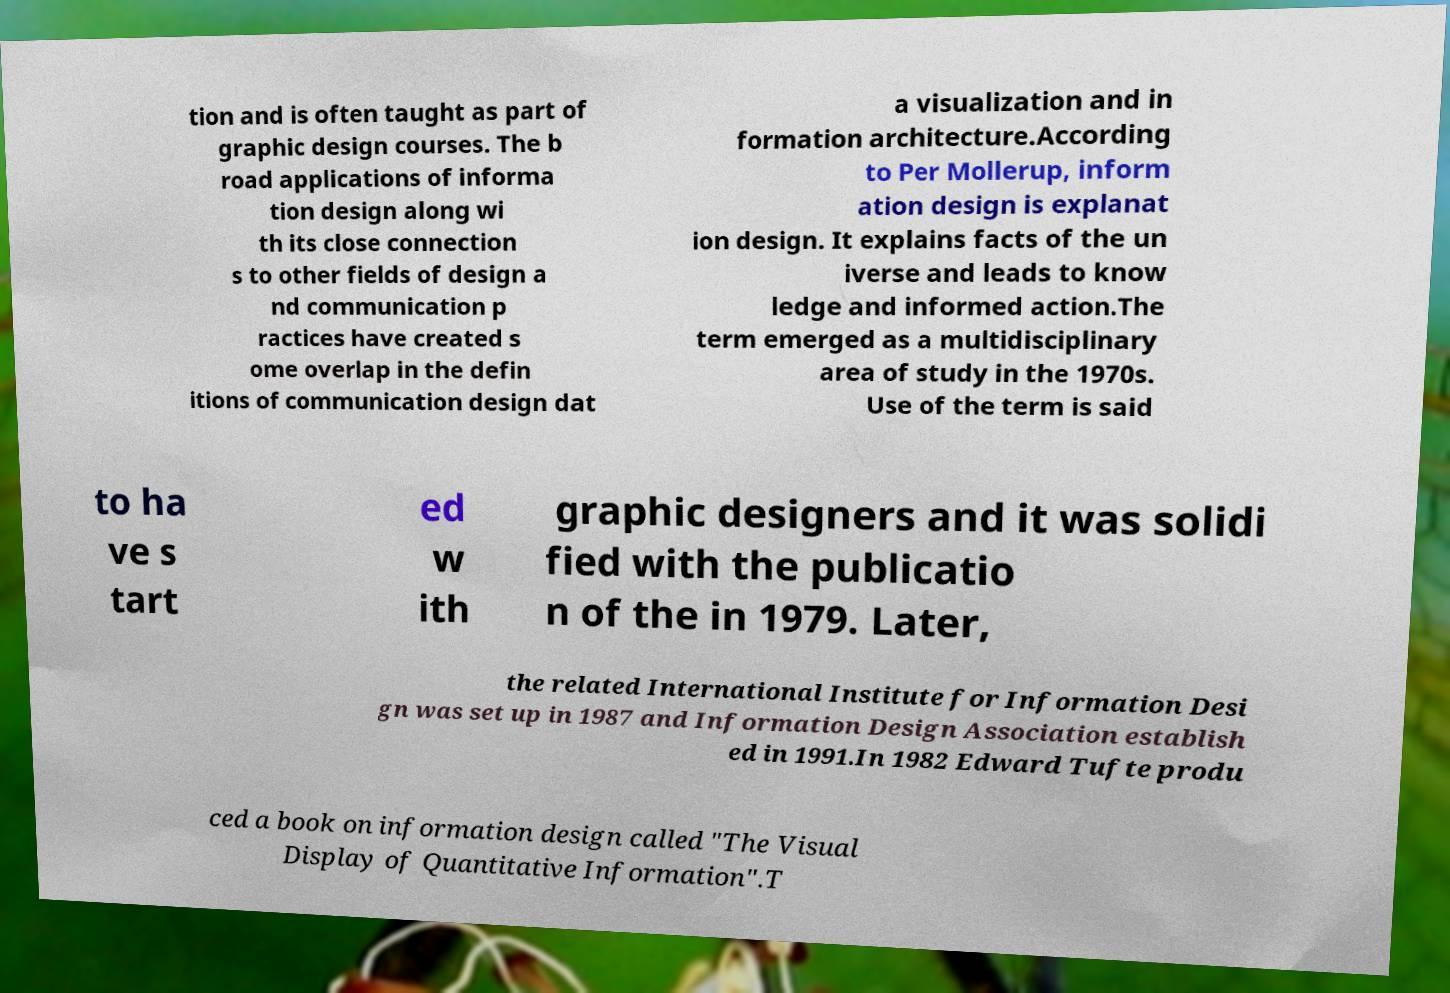Can you read and provide the text displayed in the image?This photo seems to have some interesting text. Can you extract and type it out for me? tion and is often taught as part of graphic design courses. The b road applications of informa tion design along wi th its close connection s to other fields of design a nd communication p ractices have created s ome overlap in the defin itions of communication design dat a visualization and in formation architecture.According to Per Mollerup, inform ation design is explanat ion design. It explains facts of the un iverse and leads to know ledge and informed action.The term emerged as a multidisciplinary area of study in the 1970s. Use of the term is said to ha ve s tart ed w ith graphic designers and it was solidi fied with the publicatio n of the in 1979. Later, the related International Institute for Information Desi gn was set up in 1987 and Information Design Association establish ed in 1991.In 1982 Edward Tufte produ ced a book on information design called "The Visual Display of Quantitative Information".T 